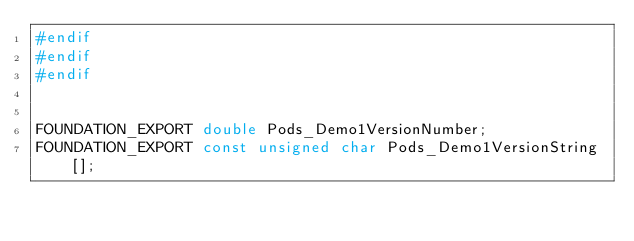<code> <loc_0><loc_0><loc_500><loc_500><_C_>#endif
#endif
#endif


FOUNDATION_EXPORT double Pods_Demo1VersionNumber;
FOUNDATION_EXPORT const unsigned char Pods_Demo1VersionString[];

</code> 